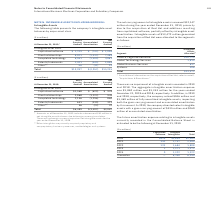According to International Business Machines's financial document, What was the additional inclusion in net intangible asset balance due to foreign currency translation? include a decrease of $42 million in net intangible asset balances due to foreign currency translation. The document states: "* Amounts as of December 31, 2019 include a decrease of $42 million in net intangible asset balances due to foreign currency translation. There was no..." Also, What are the types of other intangibles? Other intangibles are primarily acquired proprietary and nonproprietary business processes, methodologies and systems.. The document states: "** Other intangibles are primarily acquired proprietary and nonproprietary business processes, methodologies and systems...." Also, What was the gross carrying amount of total intangible assets in 2019? According to the financial document, $ 1,749 (in millions). The relevant text states: "Capitalized software $ 1,749 $ (743) $ 1,006..." Also, can you calculate: What is the increase / (decrease) in the net capitalized software from 2018 to 2019? Based on the calculation: 1,006 - 939, the result is 67 (in millions). This is based on the information: "Capitalized software $ 1,749 $ (743) $ 1,006 Capitalized software $1,568 $ (629) $ 939..." The key data points involved are: 1,006, 939. Also, can you calculate: What is the average net client relationships in 2019 and 2018? To answer this question, I need to perform calculations using the financial data. The calculation is: (7,488 + 945) / 2, which equals 4216.5 (in millions). This is based on the information: "Client relationships 8,921 (1,433) 7,488 Client relationships 2,068 (1,123) 945..." The key data points involved are: 7,488, 945. Also, can you calculate: What is the percentage increase / (decrease)  in net Completed technology from 2018 to 2019? To answer this question, I need to perform calculations using the financial data. The calculation is: (4,861 - 860)/860, which equals 465.23 (percentage). This is based on the information: "Completed technology 2,156 (1,296) 860 Completed technology 6,261 (1,400) 4,861..." The key data points involved are: 4,861, 860. 